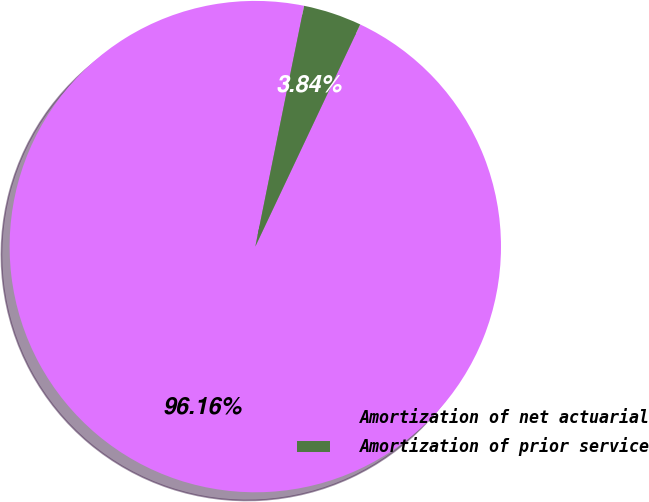Convert chart. <chart><loc_0><loc_0><loc_500><loc_500><pie_chart><fcel>Amortization of net actuarial<fcel>Amortization of prior service<nl><fcel>96.16%<fcel>3.84%<nl></chart> 